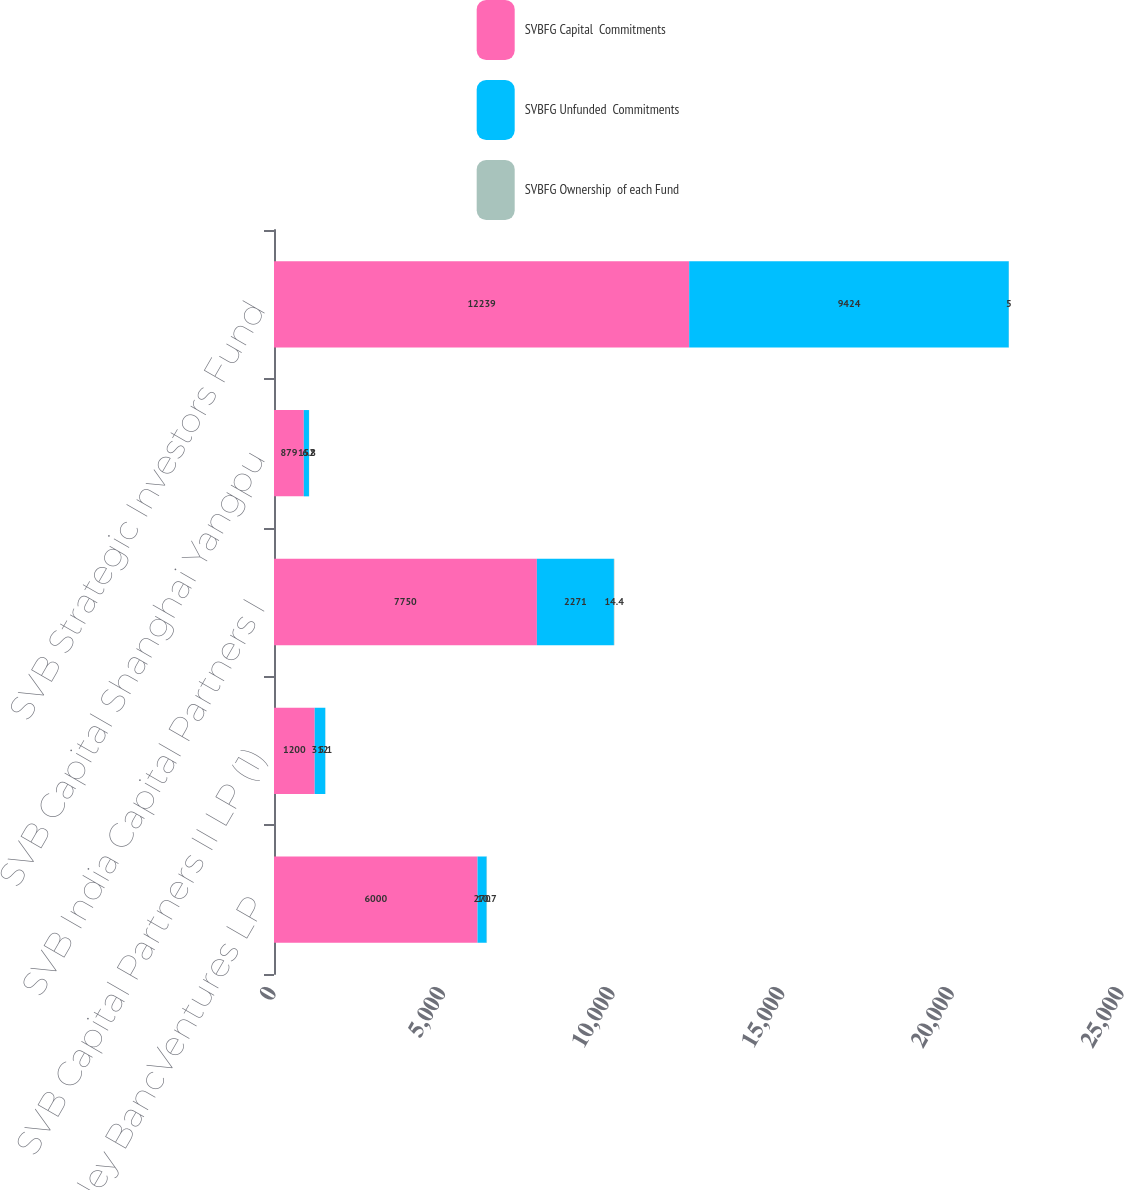Convert chart. <chart><loc_0><loc_0><loc_500><loc_500><stacked_bar_chart><ecel><fcel>Silicon Valley BancVentures LP<fcel>SVB Capital Partners II LP (1)<fcel>SVB India Capital Partners I<fcel>SVB Capital Shanghai Yangpu<fcel>SVB Strategic Investors Fund<nl><fcel>SVBFG Capital  Commitments<fcel>6000<fcel>1200<fcel>7750<fcel>879<fcel>12239<nl><fcel>SVBFG Unfunded  Commitments<fcel>270<fcel>312<fcel>2271<fcel>152<fcel>9424<nl><fcel>SVBFG Ownership  of each Fund<fcel>10.7<fcel>5.1<fcel>14.4<fcel>6.8<fcel>5<nl></chart> 